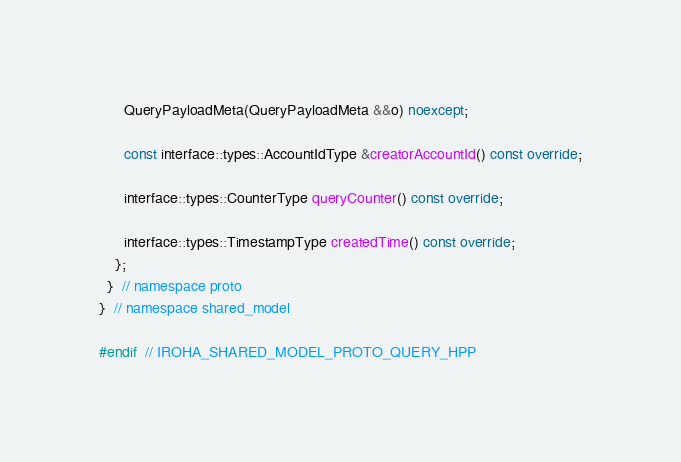<code> <loc_0><loc_0><loc_500><loc_500><_C++_>
      QueryPayloadMeta(QueryPayloadMeta &&o) noexcept;

      const interface::types::AccountIdType &creatorAccountId() const override;

      interface::types::CounterType queryCounter() const override;

      interface::types::TimestampType createdTime() const override;
    };
  }  // namespace proto
}  // namespace shared_model

#endif  // IROHA_SHARED_MODEL_PROTO_QUERY_HPP
</code> 